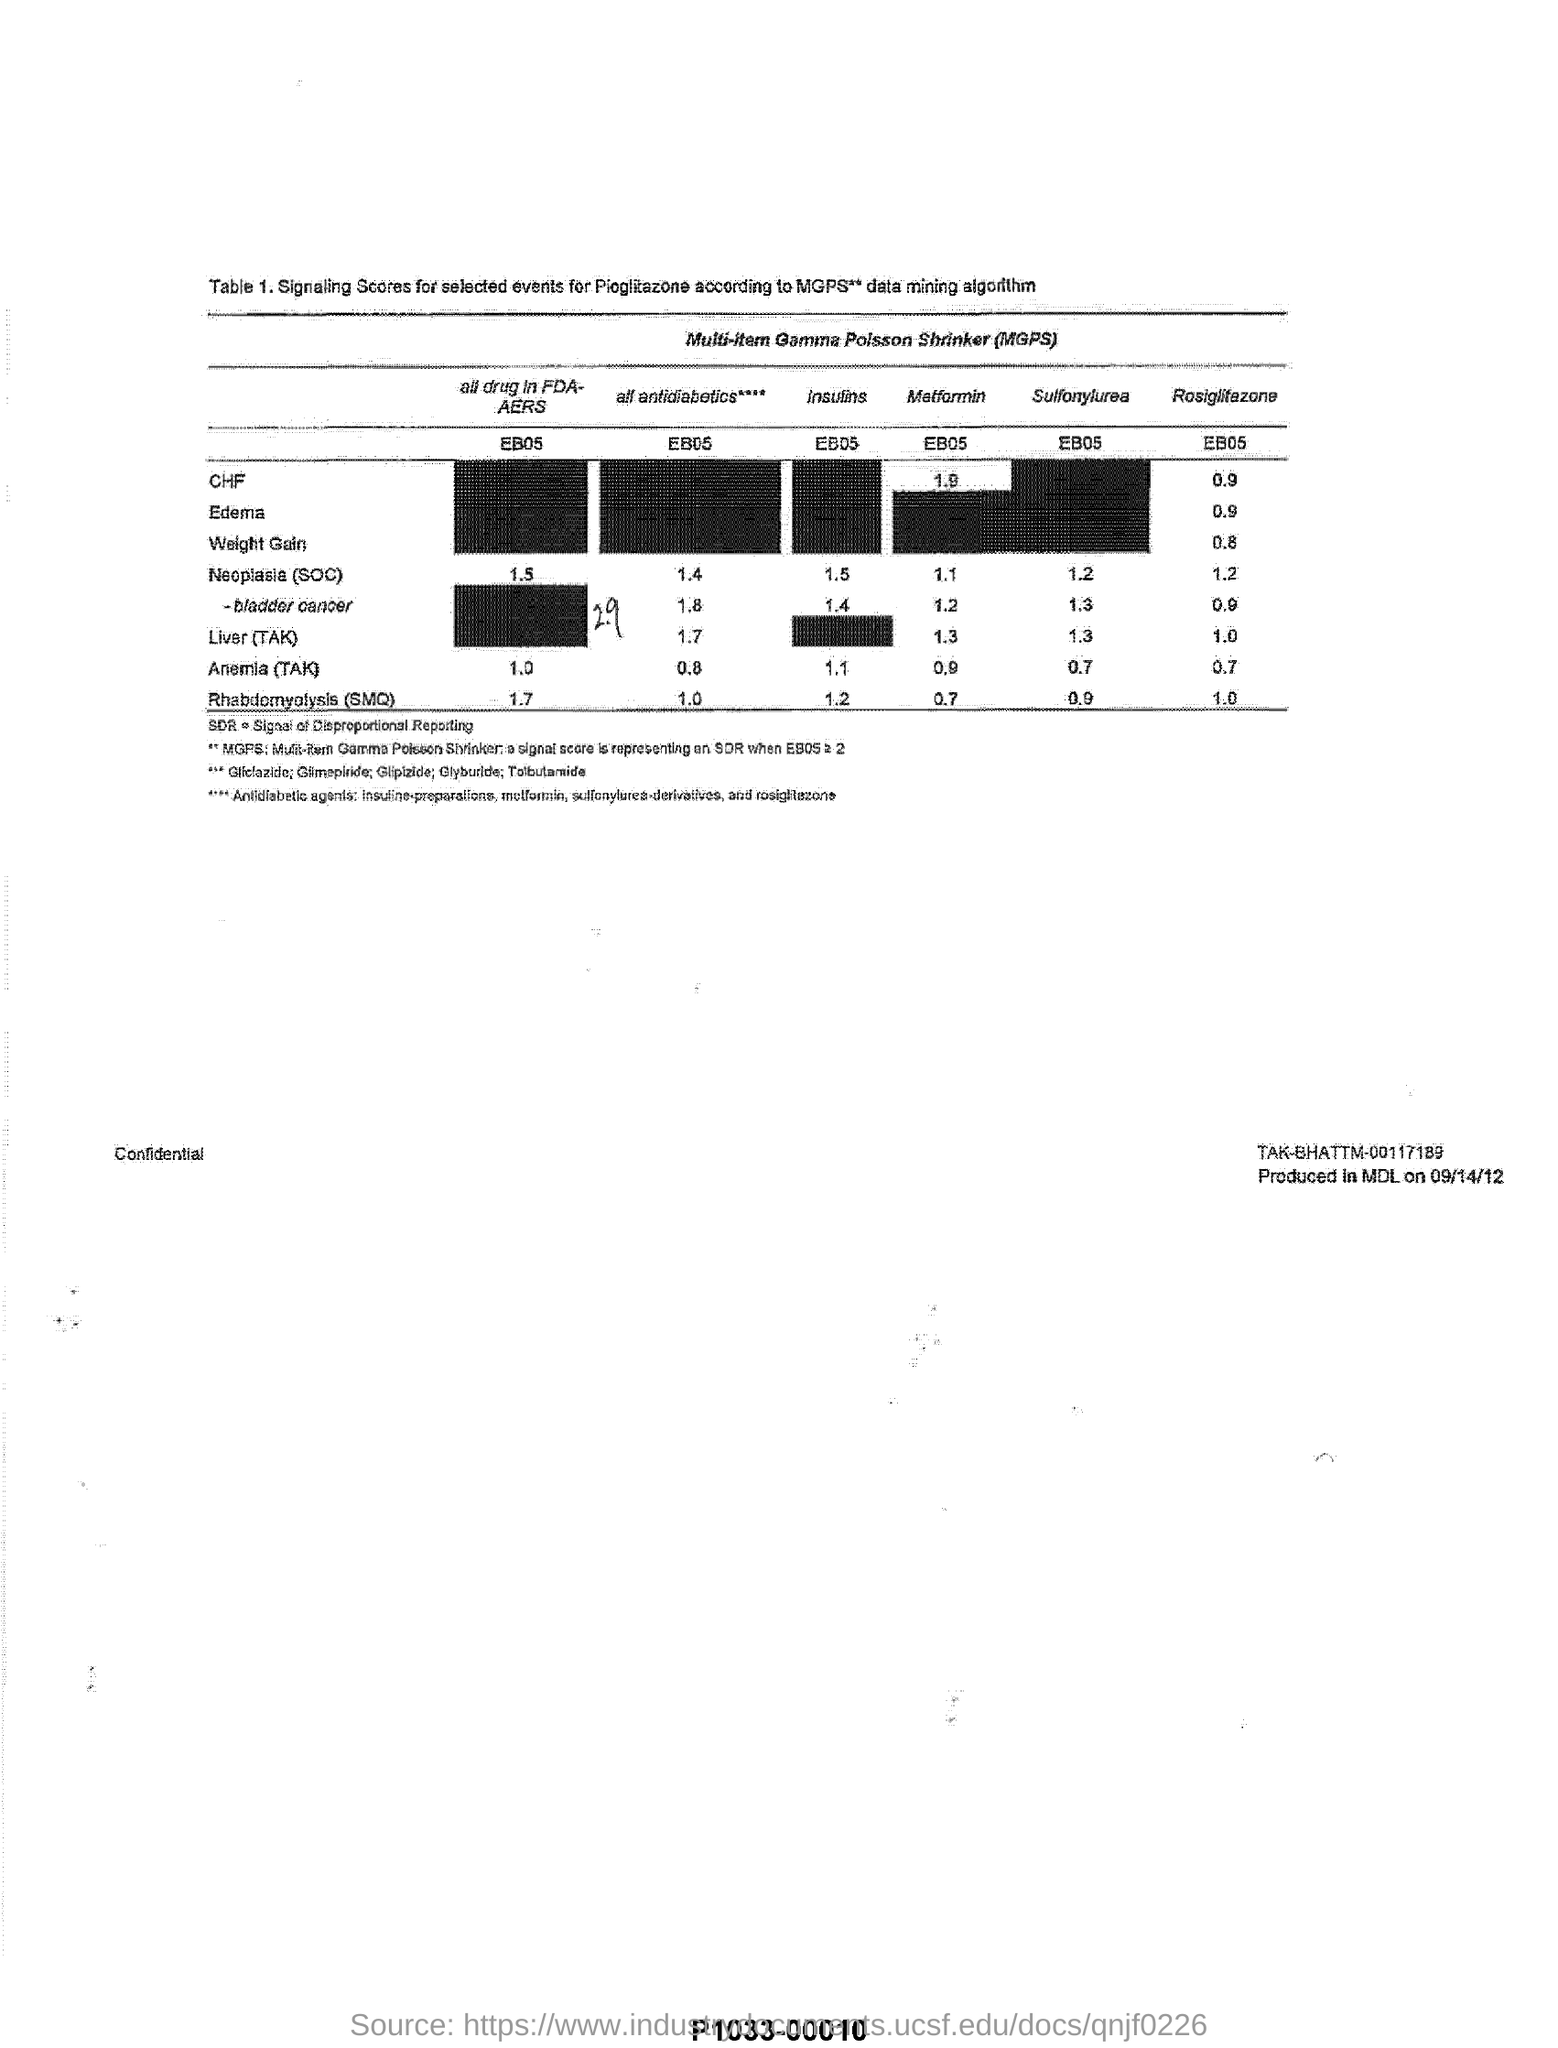Point out several critical features in this image. The MGPS** data mining algorithm is mentioned in Table 1 heading. 